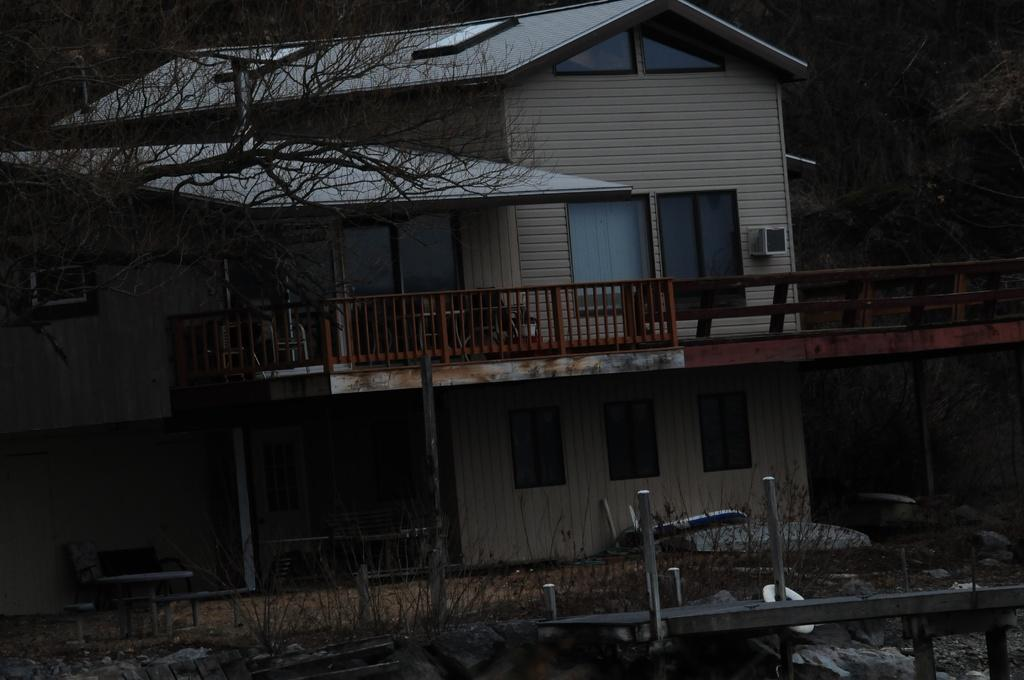What type of structures can be seen in the image? There are buildings in the image. What type of natural elements are present in the image? There are trees in the image. What type of barrier can be seen in the image? There is a fence in the image. What type of living organisms can be seen in the image? There are plants in the image. What type of apparatus is used to measure the form of the trees in the image? There is no apparatus present in the image, and the form of the trees is not being measured. What day is depicted in the image? The day is not specified in the image, as it is a still image and not a video or a series of images. 